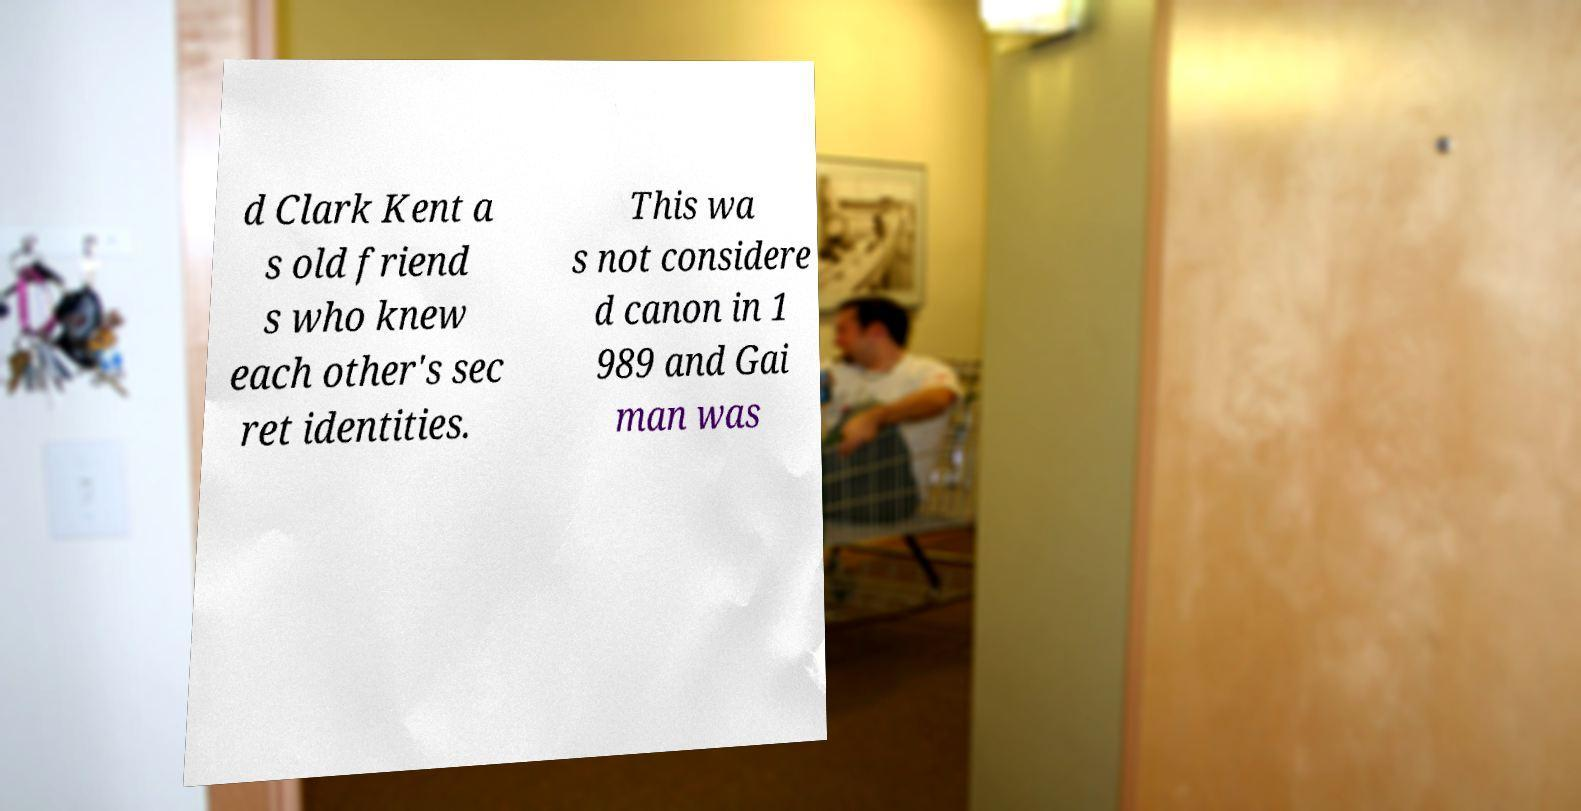Please identify and transcribe the text found in this image. d Clark Kent a s old friend s who knew each other's sec ret identities. This wa s not considere d canon in 1 989 and Gai man was 